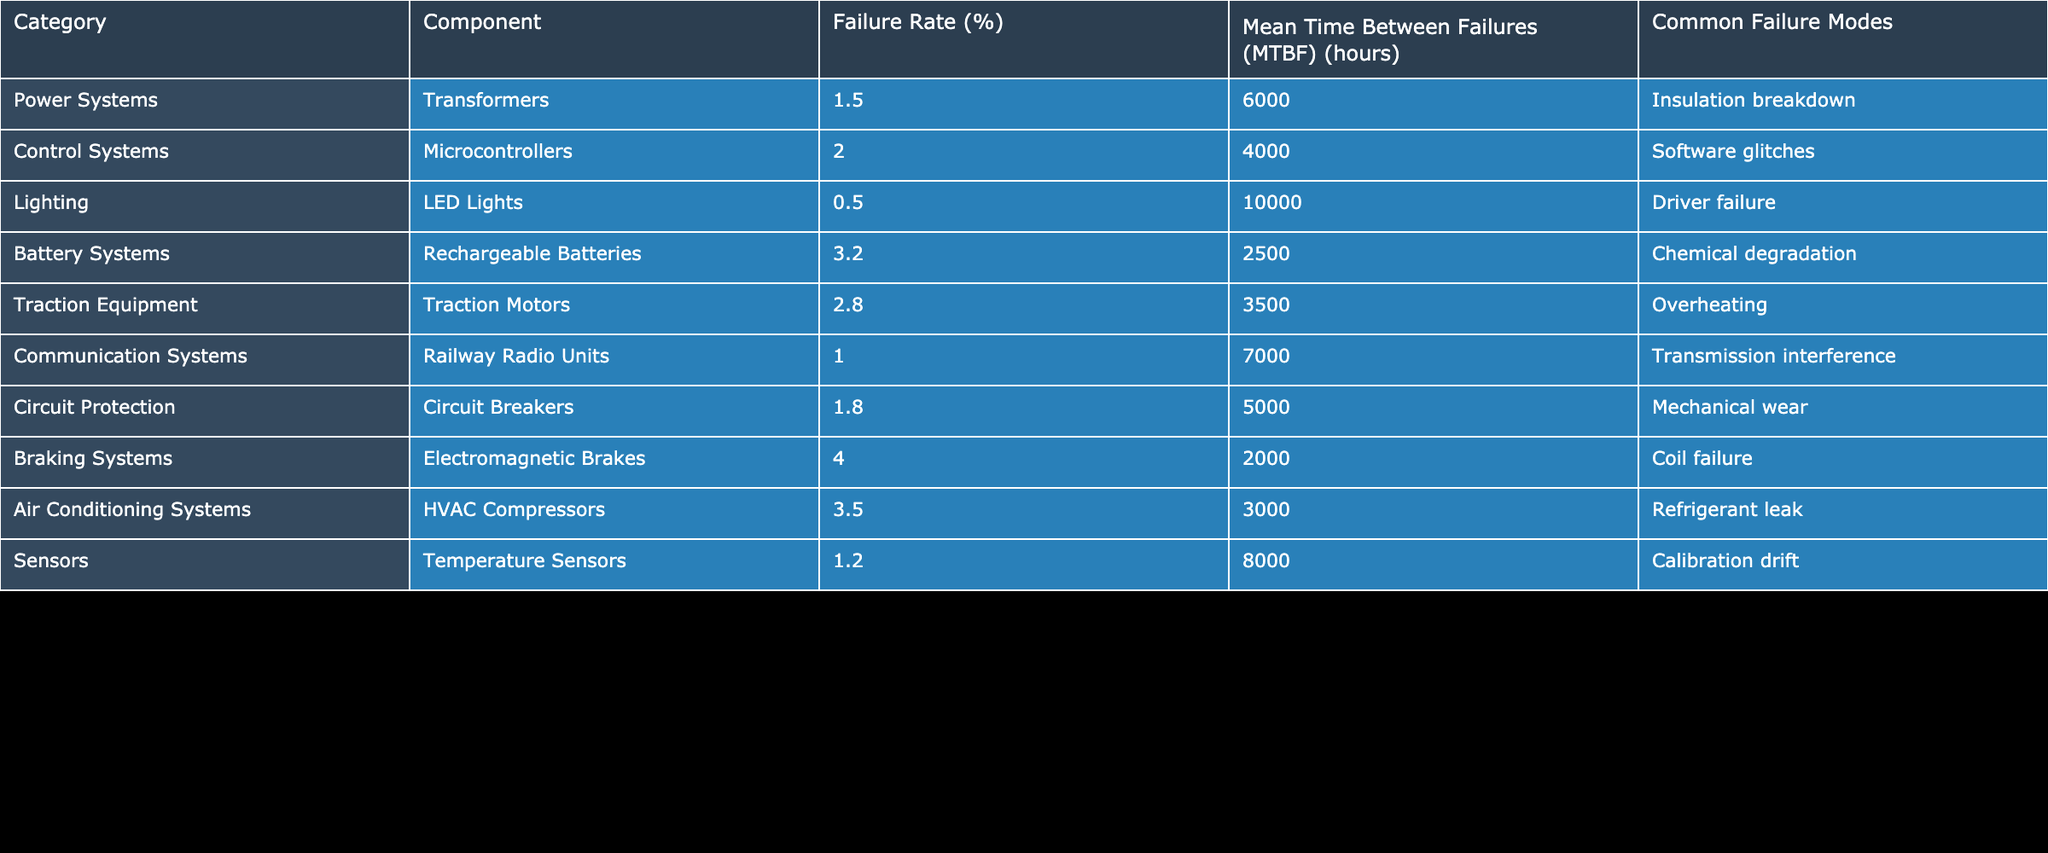What is the failure rate of rechargeable batteries? The table lists rechargeable batteries under the Battery Systems category with a failure rate of 3.2%.
Answer: 3.2% Which component has the highest failure rate? According to the table, the component with the highest failure rate is the Electromagnetic Brakes, with a failure rate of 4.0%.
Answer: 4.0% What is the mean time between failures of LED Lights? The mean time between failures (MTBF) for LED Lights is given in the table as 10000 hours.
Answer: 10000 hours How many components have a failure rate greater than 2%? By examining the table, there are four components: Rechargeable Batteries (3.2%), Traction Motors (2.8%), Electromagnetic Brakes (4.0%), and HVAC Compressors (3.5%) that have a failure rate greater than 2%.
Answer: 4 What is the average failure rate of all the components listed? We first sum the failure rates of all listed components: 1.5 + 2.0 + 0.5 + 3.2 + 2.8 + 1.0 + 1.8 + 4.0 + 3.5 + 1.2 = 20.0%. Then, we divide the total by the number of components (10) to find the average: 20.0 / 10 = 2.0%.
Answer: 2.0% Is the failure rate of traction motors higher than that of transformers? The table shows that the failure rate of traction motors is 2.8%, while transformers have a failure rate of 1.5%. Since 2.8% is greater than 1.5%, the answer is yes.
Answer: Yes What are the common failure modes for the power systems category? In the power systems category, the common failure mode listed for transformers is insulation breakdown.
Answer: Insulation breakdown Which category has the lowest average MTBF? The MTBF values need to be compared across categories. The components with the lowest MTBF are the Electromagnetic Brakes (2000 hours) and Rechargeable Batteries (2500 hours). Since 2000 hours (Braking Systems) is lower than 2500 hours, the category with the lowest average MTBF is Braking Systems.
Answer: Braking Systems 